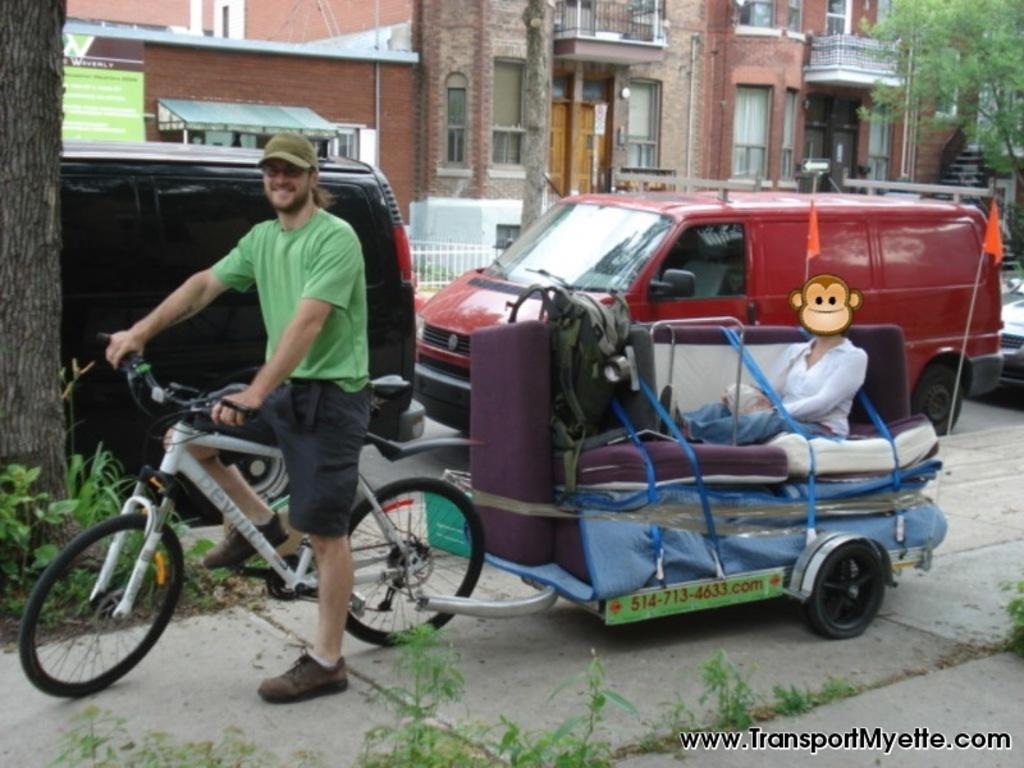In one or two sentences, can you explain what this image depicts? Here we see a man riding a bicycle and a cart attached to it and we see some parked vehicles on the road and a building and a tree 